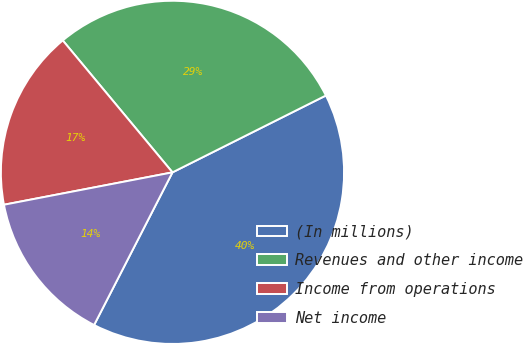<chart> <loc_0><loc_0><loc_500><loc_500><pie_chart><fcel>(In millions)<fcel>Revenues and other income<fcel>Income from operations<fcel>Net income<nl><fcel>39.94%<fcel>28.65%<fcel>16.98%<fcel>14.43%<nl></chart> 